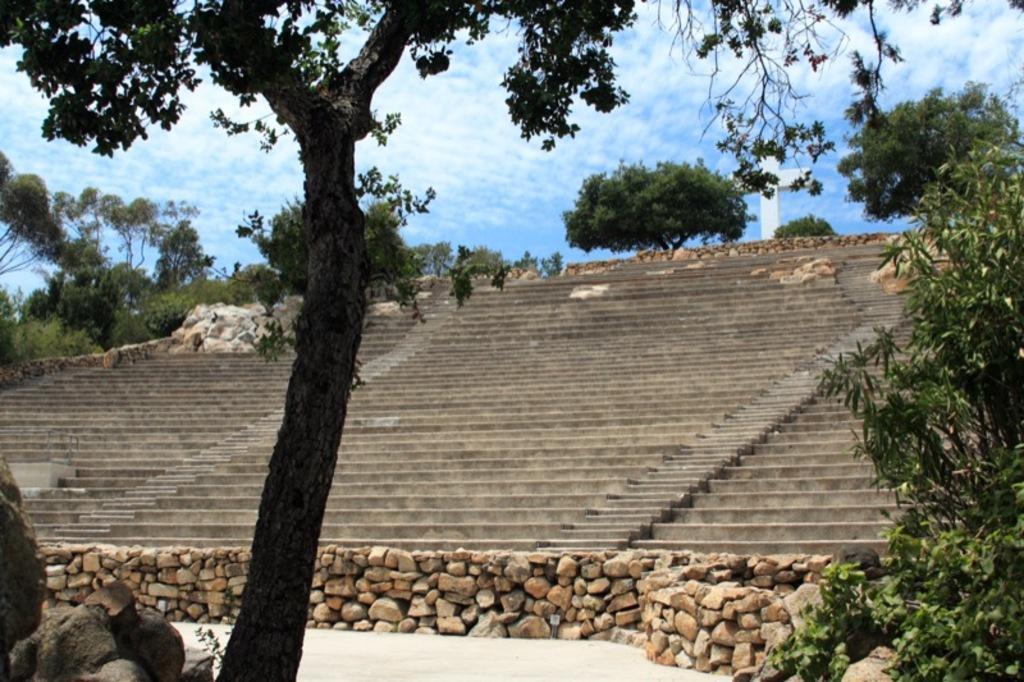Can you describe this image briefly? In this image I can see the trees, rocks and the stairs. In the background I can see many trees, cross symbol, clouds and the sky. 